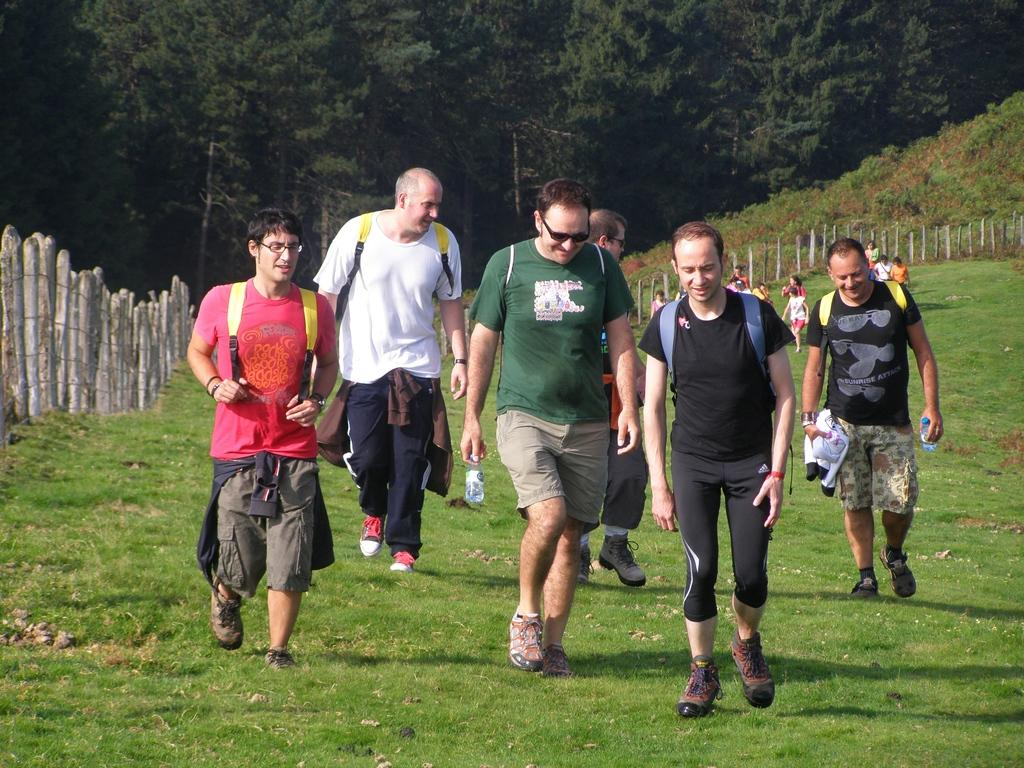What are the people in the image doing? The people in the image are walking. What are some of the people holding? Some of the people are holding bottles. What can be seen in the background of the image? There is a fence and trees in the background of the image. What type of ground is visible at the bottom of the image? Grass is present at the bottom of the image. What geographical feature is on the right side of the image? There is a hill on the right side of the image. What type of punishment is being administered to the people in the image? There is no indication of punishment in the image; the people are simply walking. What sense is being stimulated by the view in the image? The image does not provide information about which sense is being stimulated; it only shows people walking and the surrounding environment. 